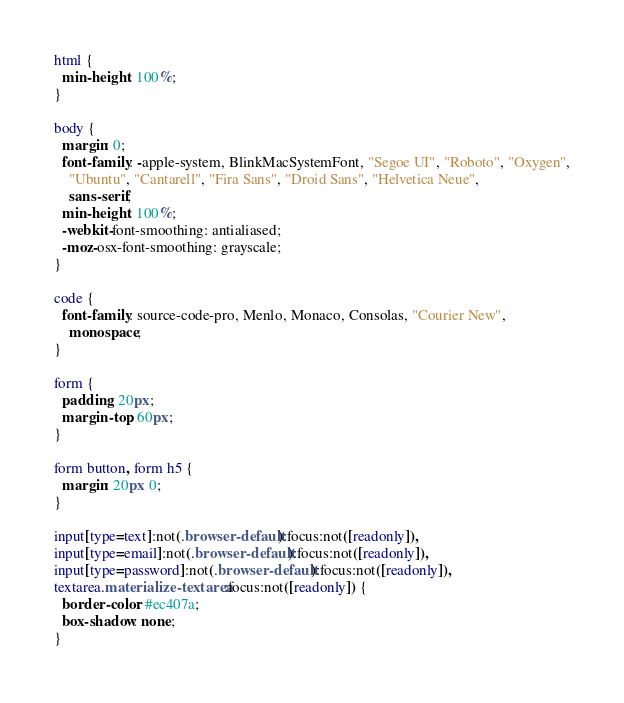Convert code to text. <code><loc_0><loc_0><loc_500><loc_500><_CSS_>html {
  min-height: 100%;
}

body {
  margin: 0;
  font-family: -apple-system, BlinkMacSystemFont, "Segoe UI", "Roboto", "Oxygen",
    "Ubuntu", "Cantarell", "Fira Sans", "Droid Sans", "Helvetica Neue",
    sans-serif;
  min-height: 100%;
  -webkit-font-smoothing: antialiased;
  -moz-osx-font-smoothing: grayscale;
}

code {
  font-family: source-code-pro, Menlo, Monaco, Consolas, "Courier New",
    monospace;
}

form {
  padding: 20px;
  margin-top: 60px;
}

form button, form h5 {
  margin: 20px 0;
}

input[type=text]:not(.browser-default):focus:not([readonly]),
input[type=email]:not(.browser-default):focus:not([readonly]),
input[type=password]:not(.browser-default):focus:not([readonly]),
textarea.materialize-textarea:focus:not([readonly]) {
  border-color: #ec407a;
  box-shadow: none;
}
</code> 